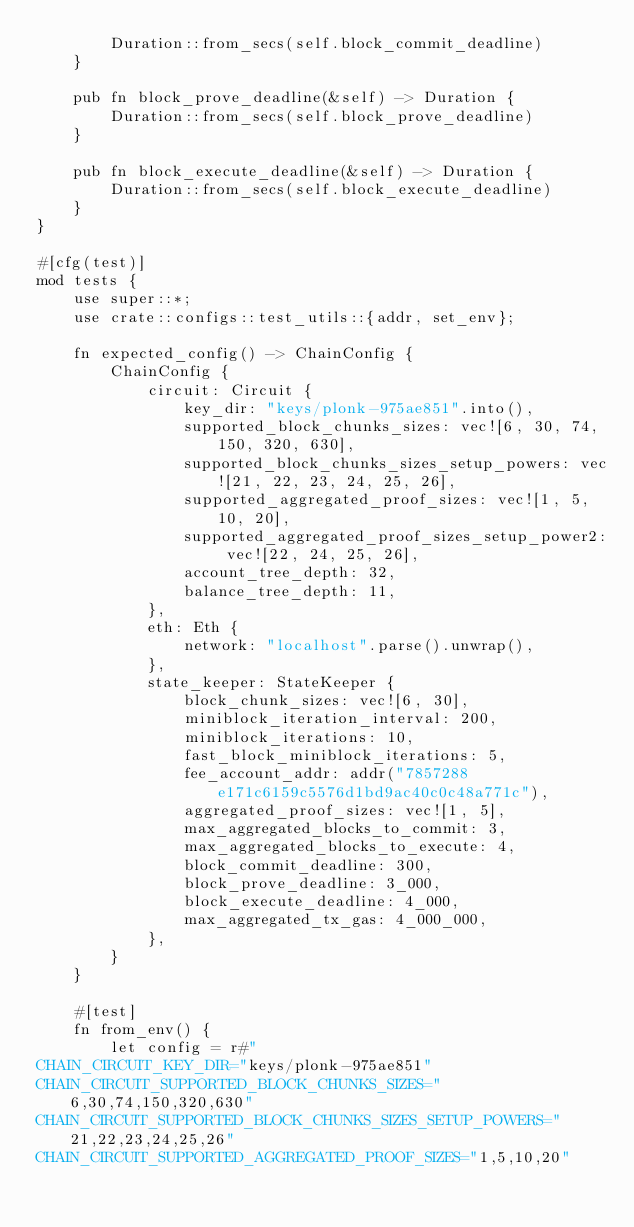Convert code to text. <code><loc_0><loc_0><loc_500><loc_500><_Rust_>        Duration::from_secs(self.block_commit_deadline)
    }

    pub fn block_prove_deadline(&self) -> Duration {
        Duration::from_secs(self.block_prove_deadline)
    }

    pub fn block_execute_deadline(&self) -> Duration {
        Duration::from_secs(self.block_execute_deadline)
    }
}

#[cfg(test)]
mod tests {
    use super::*;
    use crate::configs::test_utils::{addr, set_env};

    fn expected_config() -> ChainConfig {
        ChainConfig {
            circuit: Circuit {
                key_dir: "keys/plonk-975ae851".into(),
                supported_block_chunks_sizes: vec![6, 30, 74, 150, 320, 630],
                supported_block_chunks_sizes_setup_powers: vec![21, 22, 23, 24, 25, 26],
                supported_aggregated_proof_sizes: vec![1, 5, 10, 20],
                supported_aggregated_proof_sizes_setup_power2: vec![22, 24, 25, 26],
                account_tree_depth: 32,
                balance_tree_depth: 11,
            },
            eth: Eth {
                network: "localhost".parse().unwrap(),
            },
            state_keeper: StateKeeper {
                block_chunk_sizes: vec![6, 30],
                miniblock_iteration_interval: 200,
                miniblock_iterations: 10,
                fast_block_miniblock_iterations: 5,
                fee_account_addr: addr("7857288e171c6159c5576d1bd9ac40c0c48a771c"),
                aggregated_proof_sizes: vec![1, 5],
                max_aggregated_blocks_to_commit: 3,
                max_aggregated_blocks_to_execute: 4,
                block_commit_deadline: 300,
                block_prove_deadline: 3_000,
                block_execute_deadline: 4_000,
                max_aggregated_tx_gas: 4_000_000,
            },
        }
    }

    #[test]
    fn from_env() {
        let config = r#"
CHAIN_CIRCUIT_KEY_DIR="keys/plonk-975ae851"
CHAIN_CIRCUIT_SUPPORTED_BLOCK_CHUNKS_SIZES="6,30,74,150,320,630"
CHAIN_CIRCUIT_SUPPORTED_BLOCK_CHUNKS_SIZES_SETUP_POWERS="21,22,23,24,25,26"
CHAIN_CIRCUIT_SUPPORTED_AGGREGATED_PROOF_SIZES="1,5,10,20"</code> 